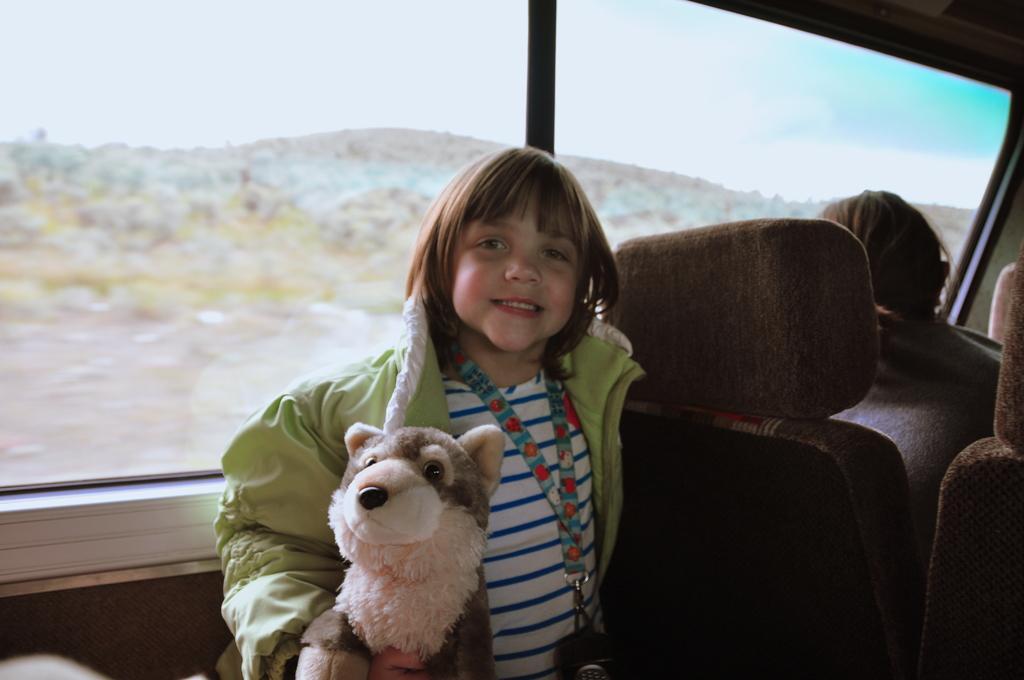Could you give a brief overview of what you see in this image? This picture is clicked inside a vehicle. There are two people in the image. The girl at the center is wearing a green jacket, a tag and holding a toy in her hand. There is another person sitting to the right corner of the image. Through the window we can see sky and mountains. 